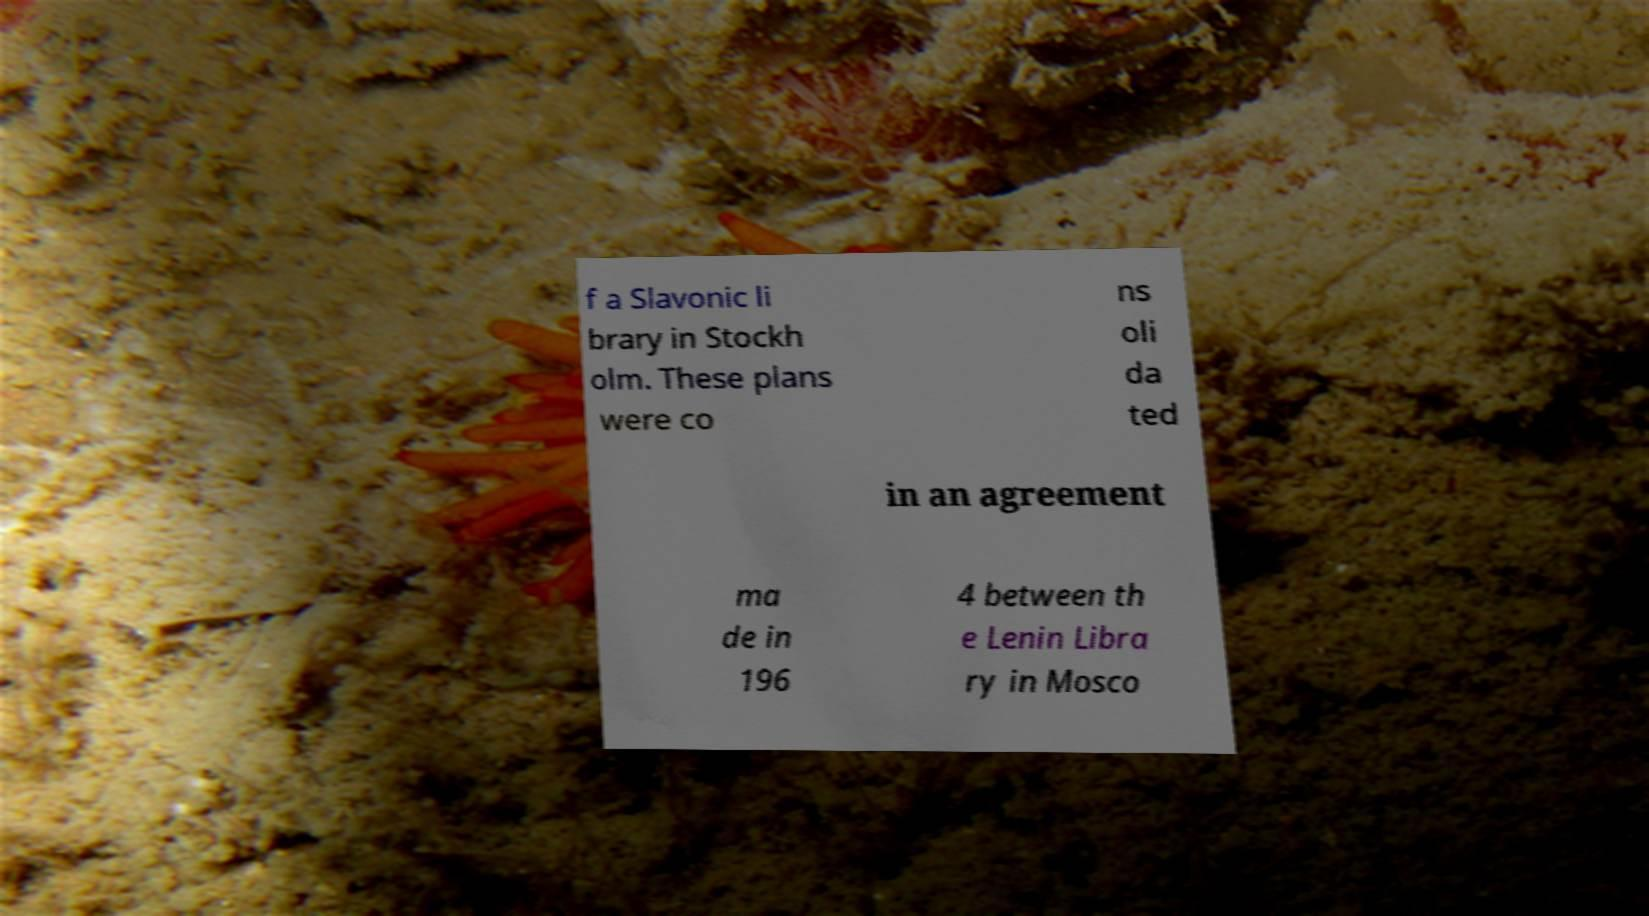Can you read and provide the text displayed in the image?This photo seems to have some interesting text. Can you extract and type it out for me? f a Slavonic li brary in Stockh olm. These plans were co ns oli da ted in an agreement ma de in 196 4 between th e Lenin Libra ry in Mosco 